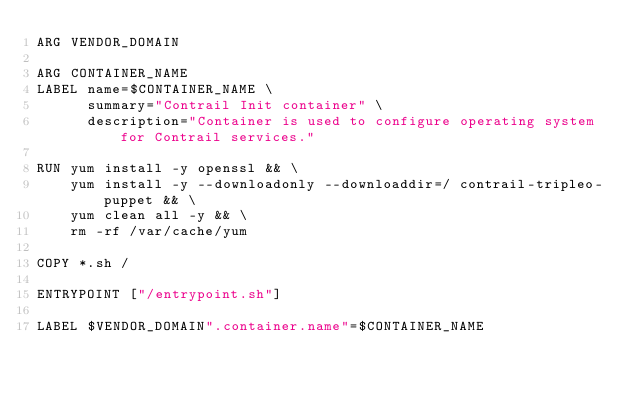<code> <loc_0><loc_0><loc_500><loc_500><_Dockerfile_>ARG VENDOR_DOMAIN

ARG CONTAINER_NAME
LABEL name=$CONTAINER_NAME \
      summary="Contrail Init container" \
      description="Container is used to configure operating system for Contrail services."

RUN yum install -y openssl && \
    yum install -y --downloadonly --downloaddir=/ contrail-tripleo-puppet && \
    yum clean all -y && \
    rm -rf /var/cache/yum

COPY *.sh /

ENTRYPOINT ["/entrypoint.sh"]

LABEL $VENDOR_DOMAIN".container.name"=$CONTAINER_NAME
</code> 